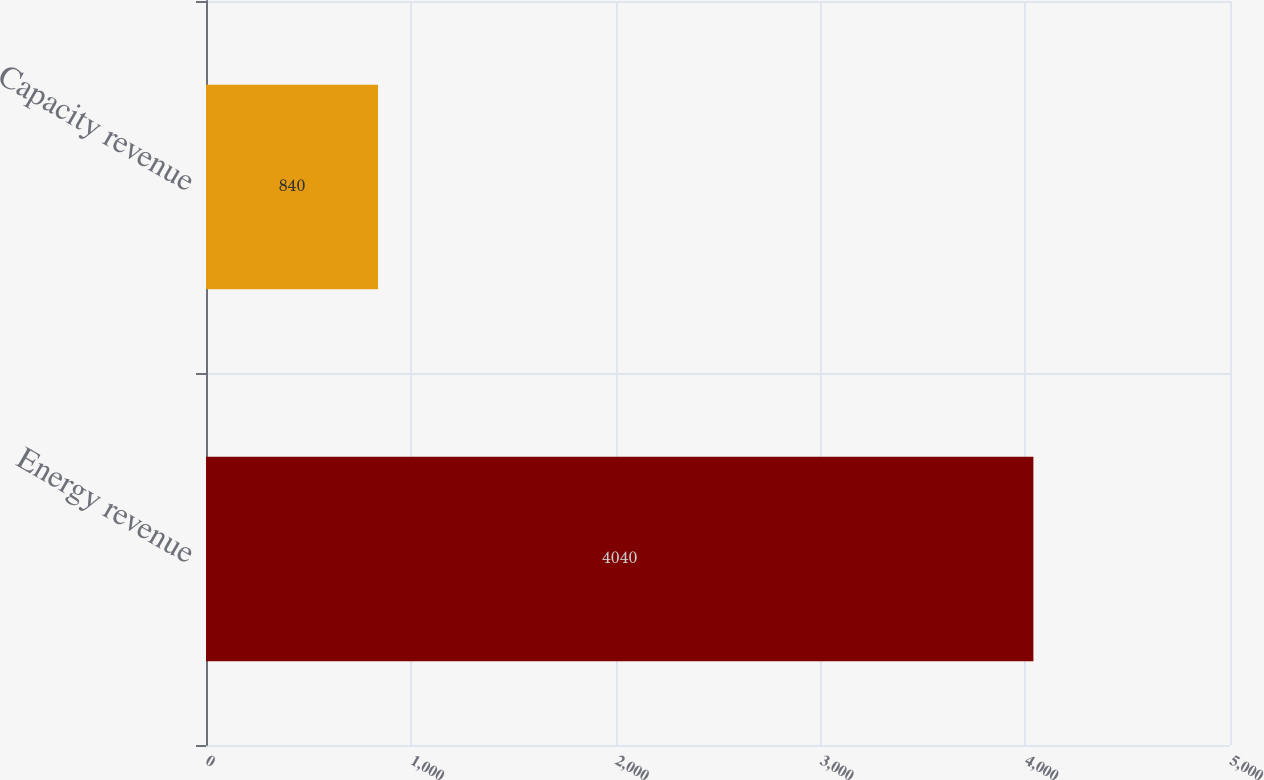Convert chart to OTSL. <chart><loc_0><loc_0><loc_500><loc_500><bar_chart><fcel>Energy revenue<fcel>Capacity revenue<nl><fcel>4040<fcel>840<nl></chart> 